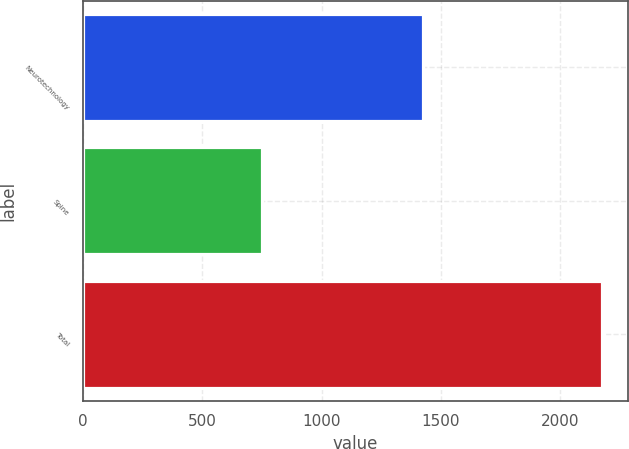Convert chart. <chart><loc_0><loc_0><loc_500><loc_500><bar_chart><fcel>Neurotechnology<fcel>Spine<fcel>Total<nl><fcel>1423<fcel>751<fcel>2174<nl></chart> 